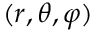Convert formula to latex. <formula><loc_0><loc_0><loc_500><loc_500>( r , \theta , \varphi )</formula> 